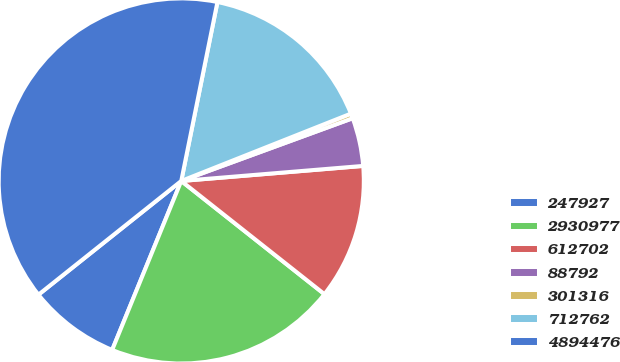<chart> <loc_0><loc_0><loc_500><loc_500><pie_chart><fcel>247927<fcel>2930977<fcel>612702<fcel>88792<fcel>301316<fcel>712762<fcel>4894476<nl><fcel>8.12%<fcel>20.53%<fcel>11.96%<fcel>4.27%<fcel>0.43%<fcel>15.81%<fcel>38.88%<nl></chart> 